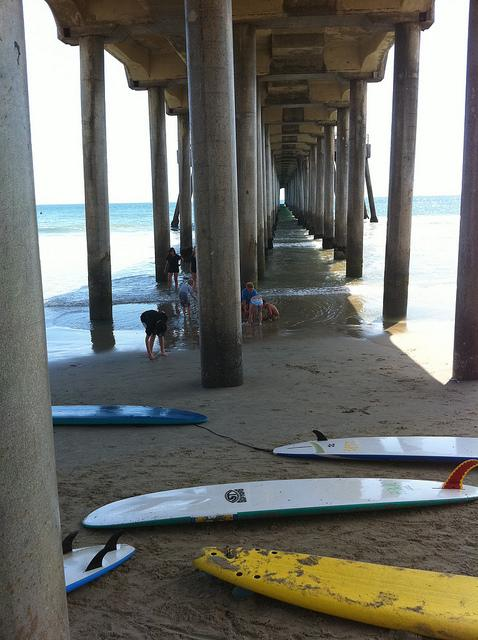What colour is the board on the bottom right? Please explain your reasoning. yellow. It is the same color as a banana 